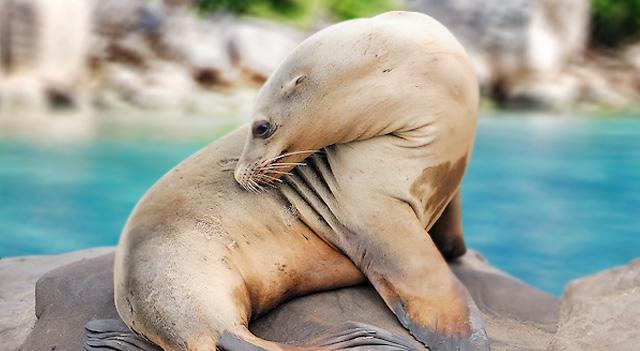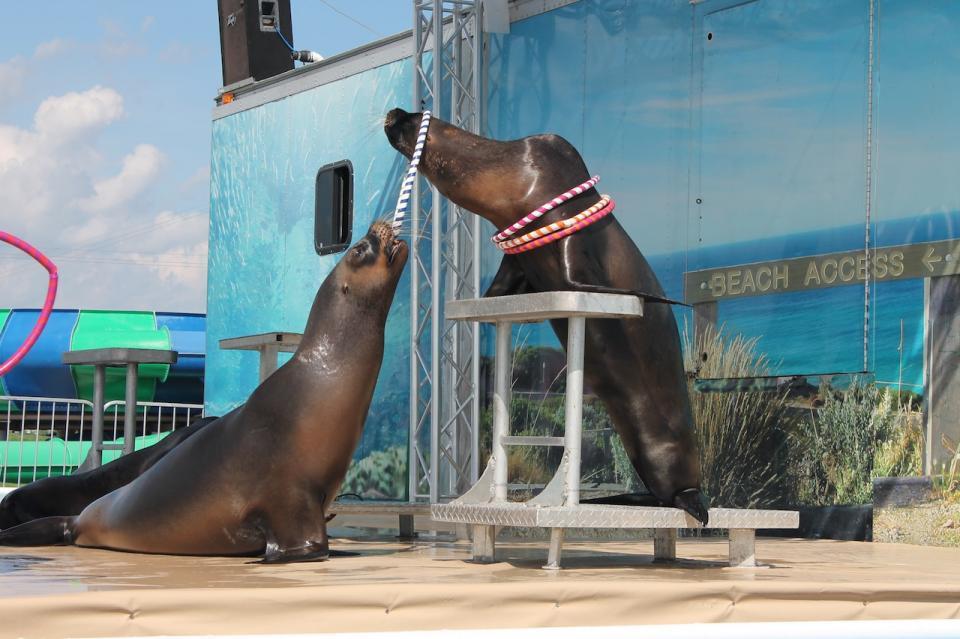The first image is the image on the left, the second image is the image on the right. For the images displayed, is the sentence "Each image shows exactly one seal with raised head and water in the background, and one of the depicted seals faces left, while the other faces right." factually correct? Answer yes or no. No. The first image is the image on the left, the second image is the image on the right. Assess this claim about the two images: "The right image contains at least two seals.". Correct or not? Answer yes or no. Yes. 